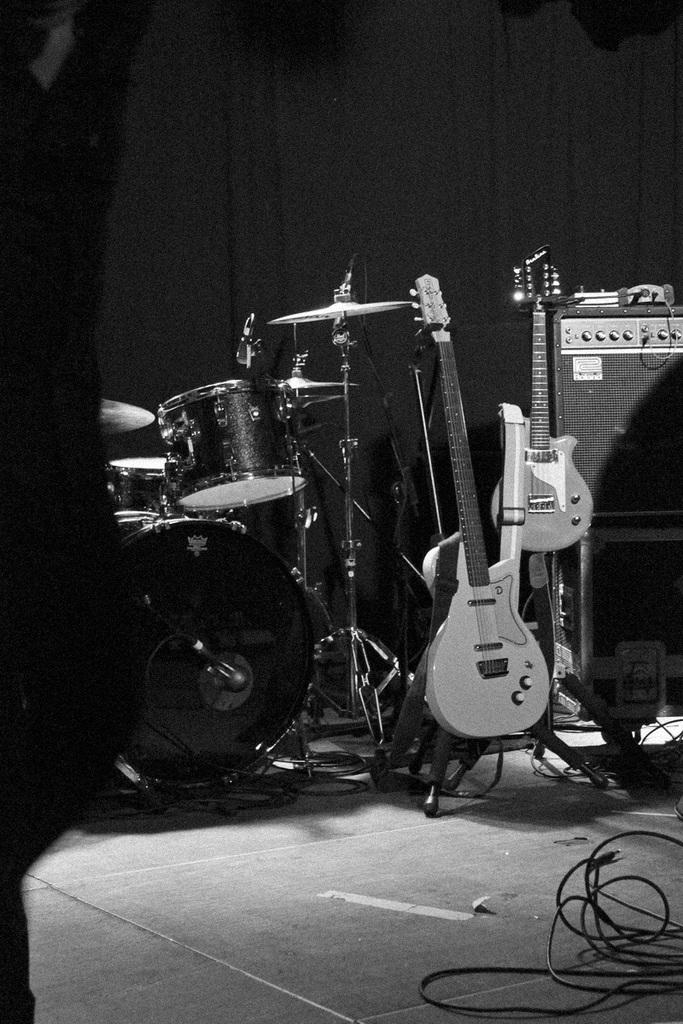What objects can be seen in the image that are related to music? There are musical instruments in the image. What can be found on the ground at the bottom of the image? There are cables placed on the ground at the bottom of the image. Can you describe the person in the image? There is a person at the left side of the image. What type of holiday is being celebrated in the image? There is no indication of a holiday being celebrated in the image. Can you see any bones in the image? There are no bones visible in the image. 